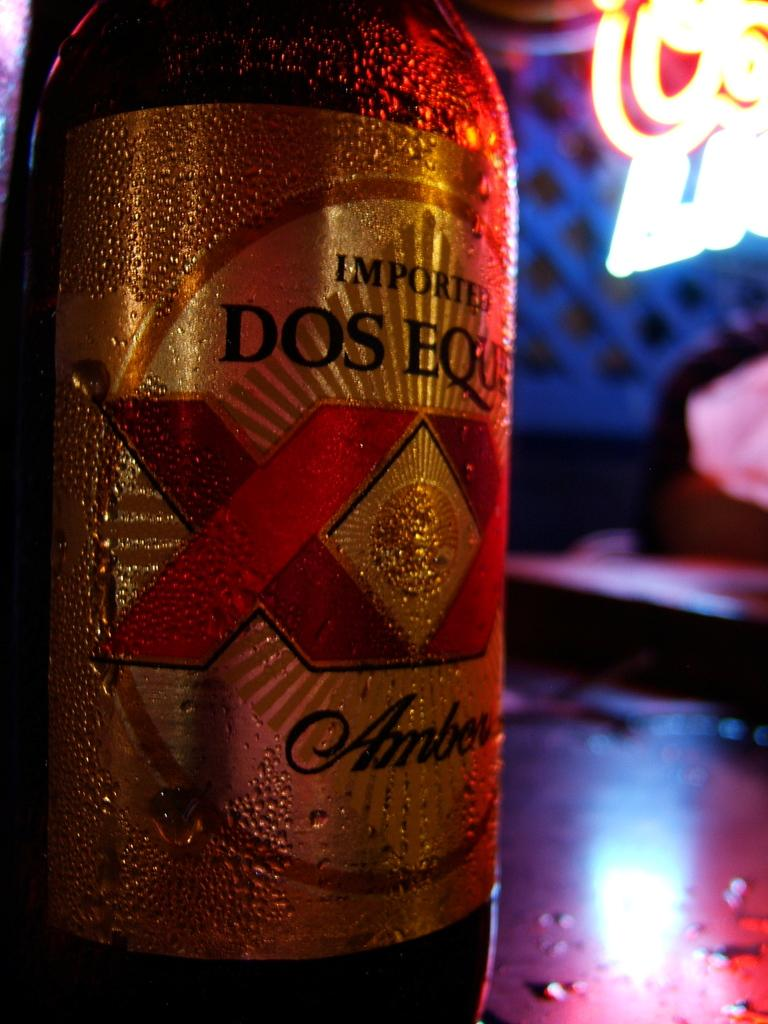Provide a one-sentence caption for the provided image. The cold, imported Dos Equs Amber perspired in the heat. 